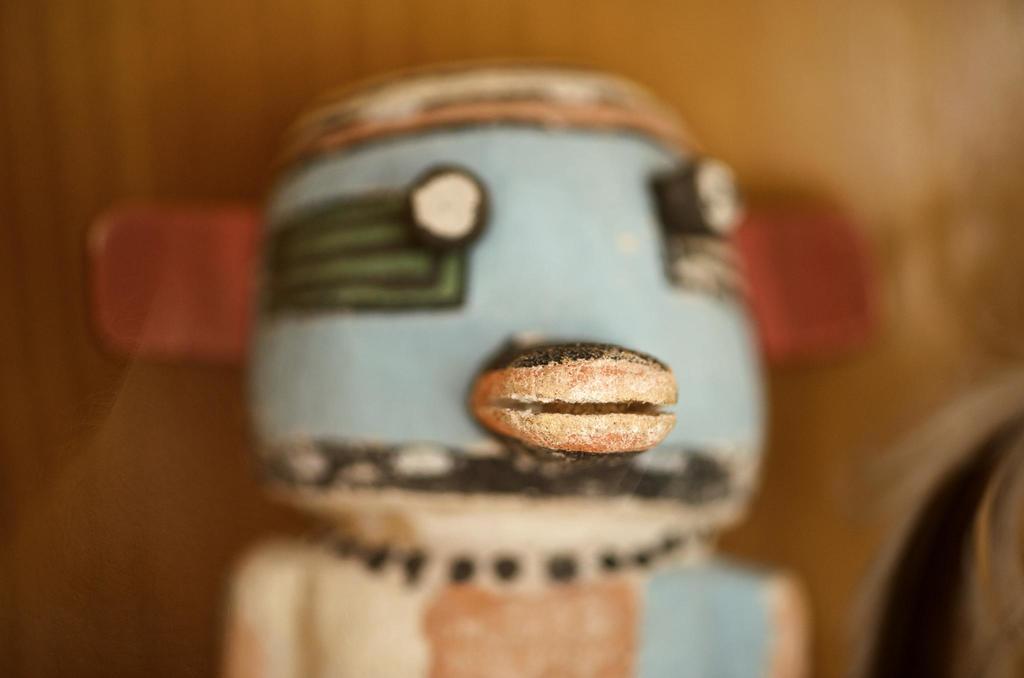Please provide a concise description of this image. This is a zoomed in picture. In the center there is an object seems to be the toy. The background of the image is blurry and there are some objects in the background. 